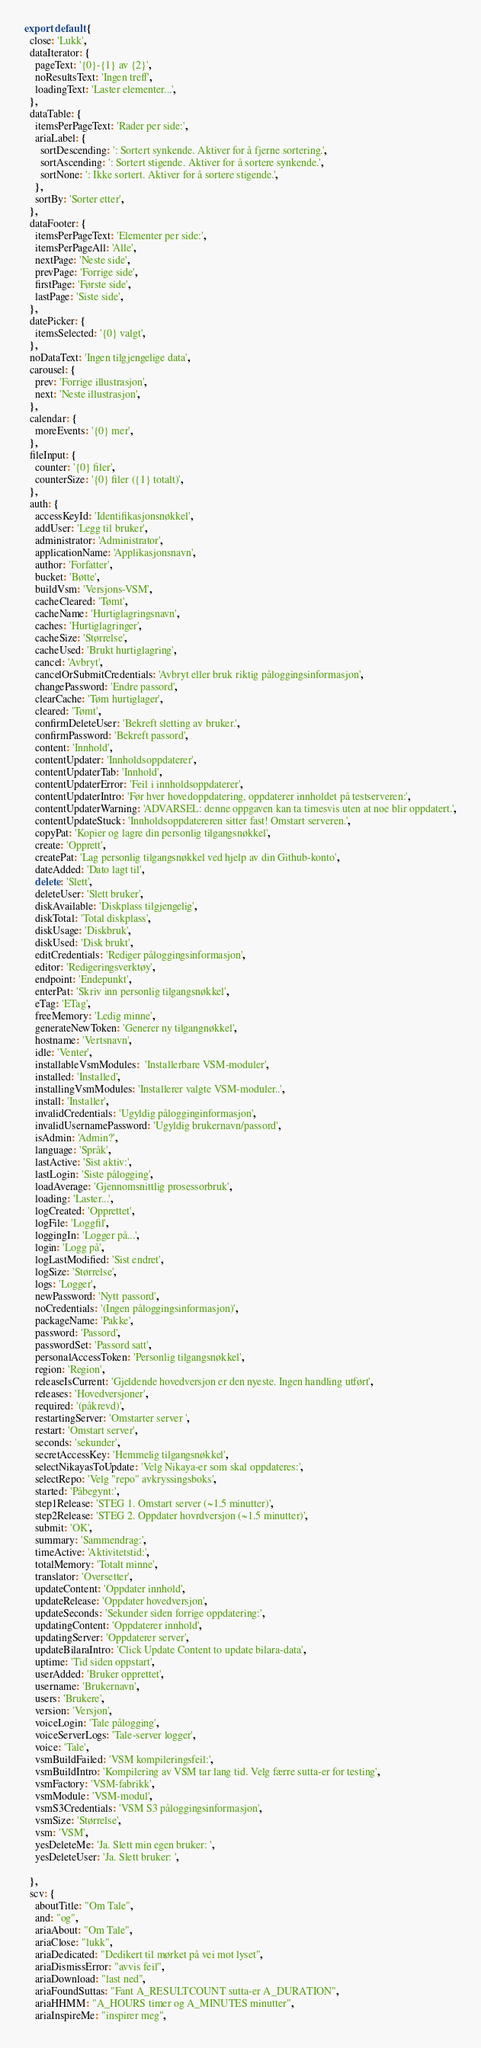<code> <loc_0><loc_0><loc_500><loc_500><_TypeScript_>export default {
  close: 'Lukk',
  dataIterator: {
    pageText: '{0}-{1} av {2}',
    noResultsText: 'Ingen treff',
    loadingText: 'Laster elementer...',
  },
  dataTable: {
    itemsPerPageText: 'Rader per side:',
    ariaLabel: {
      sortDescending: ': Sortert synkende. Aktiver for å fjerne sortering.',
      sortAscending: ': Sortert stigende. Aktiver for å sortere synkende.',
      sortNone: ': Ikke sortert. Aktiver for å sortere stigende.',
    },
    sortBy: 'Sorter etter',
  },
  dataFooter: {
    itemsPerPageText: 'Elementer per side:',
    itemsPerPageAll: 'Alle',
    nextPage: 'Neste side',
    prevPage: 'Forrige side',
    firstPage: 'Første side',
    lastPage: 'Siste side',
  },
  datePicker: {
    itemsSelected: '{0} valgt',
  },
  noDataText: 'Ingen tilgjengelige data',
  carousel: {
    prev: 'Forrige illustrasjon',
    next: 'Neste illustrasjon',
  },
  calendar: {
    moreEvents: '{0} mer',
  },
  fileInput: {
    counter: '{0} filer',
    counterSize: '{0} filer ({1} totalt)',
  },
  auth: {
    accessKeyId: 'Identifikasjonsnøkkel',
    addUser: 'Legg til bruker',
    administrator: 'Administrator',
    applicationName: 'Applikasjonsnavn',
    author: 'Forfatter',
    bucket: 'Bøtte',
    buildVsm: 'Versjons-VSM',
    cacheCleared: 'Tømt',
    cacheName: 'Hurtiglagringsnavn',
    caches: 'Hurtiglagringer',
    cacheSize: 'Størrelse',
    cacheUsed: 'Brukt hurtiglagring',
    cancel: 'Avbryt',
    cancelOrSubmitCredentials: 'Avbryt eller bruk riktig påloggingsinformasjon',
    changePassword: 'Endre passord',
    clearCache: 'Tøm hurtiglager',
    cleared: 'Tømt',
    confirmDeleteUser: 'Bekreft sletting av bruker.',
    confirmPassword: 'Bekreft passord',
    content: 'Innhold',
    contentUpdater: 'Innholdsoppdaterer',
    contentUpdaterTab: 'Innhold',
    contentUpdaterError: 'Feil i innholdsoppdaterer',
    contentUpdaterIntro: 'Før hver hovedoppdatering, oppdaterer innholdet på testserveren:',
    contentUpdaterWarning: 'ADVARSEL: denne oppgaven kan ta timesvis uten at noe blir oppdatert.',
    contentUpdateStuck: 'Innholdsoppdatereren sitter fast! Omstart serveren.',
    copyPat: 'Kopier og lagre din personlig tilgangsnøkkel',
    create: 'Opprett',
    createPat: 'Lag personlig tilgangsnøkkel ved hjelp av din Github-konto',
    dateAdded: 'Dato lagt til',
    delete: 'Slett',
    deleteUser: 'Slett bruker',
    diskAvailable: 'Diskplass tilgjengelig',
    diskTotal: 'Total diskplass',
    diskUsage: 'Diskbruk',
    diskUsed: 'Disk brukt',
    editCredentials: 'Rediger påloggingsinformasjon',
    editor: 'Redigeringsverktøy',
    endpoint: 'Endepunkt',
    enterPat: 'Skriv inn personlig tilgangsnøkkel',
    eTag: 'ETag',
    freeMemory: 'Ledig minne',
    generateNewToken: 'Generer ny tilgangnøkkel',
    hostname: 'Vertsnavn',
    idle: 'Venter',
    installableVsmModules:  'Installerbare VSM-moduler',
    installed: 'Installed',
    installingVsmModules: 'Installerer valgte VSM-moduler..',
    install: 'Installer',
    invalidCredentials: 'Ugyldig pålogginginformasjon',
    invalidUsernamePassword: 'Ugyldig brukernavn/passord',
    isAdmin: 'Admin?',
    language: 'Språk',
    lastActive: 'Sist aktiv:',
    lastLogin: 'Siste pålogging',
    loadAverage: 'Gjennomsnittlig prosessorbruk',
    loading: 'Laster...',
    logCreated: 'Opprettet',
    logFile: 'Loggfil',
    loggingIn: 'Logger på...',
    login: 'Logg på',
    logLastModified: 'Sist endret',
    logSize: 'Størrelse',
    logs: 'Logger',
    newPassword: 'Nytt passord',
    noCredentials: '(Ingen påloggingsinformasjon)',
    packageName: 'Pakke',
    password: 'Passord',
    passwordSet: 'Passord satt',
    personalAccessToken: 'Personlig tilgangsnøkkel',
    region: 'Region',
    releaseIsCurrent: 'Gjeldende hovedversjon er den nyeste. Ingen handling utført',
    releases: 'Hovedversjoner',
    required: '(påkrevd)',
    restartingServer: 'Omstarter server ',
    restart: 'Omstart server',
    seconds: 'sekunder',
    secretAccessKey: 'Hemmelig tilgangsnøkkel',
    selectNikayasToUpdate: 'Velg Nikaya-er som skal oppdateres:',
    selectRepo: 'Velg "repo" avkryssingsboks',
    started: 'Påbegynt:',
    step1Release: 'STEG 1. Omstart server (~1.5 minutter)',
    step2Release: 'STEG 2. Oppdater hovrdversjon (~1.5 minutter)',
    submit: 'OK',
    summary: 'Sammendrag:',
    timeActive: 'Aktivitetstid:',
    totalMemory: 'Totalt minne',
    translator: 'Oversetter',
    updateContent: 'Oppdater innhold',
    updateRelease: 'Oppdater hovedversjon',
    updateSeconds: 'Sekunder siden forrige oppdatering:',
    updatingContent: 'Oppdaterer innhold',
    updatingServer: 'Oppdaterer server',
    updateBilaraIntro: 'Click Update Content to update bilara-data',
    uptime: 'Tid siden oppstart',
    userAdded: 'Bruker opprettet',
    username: 'Brukernavn',
    users: 'Brukere',
    version: 'Versjon',
    voiceLogin: 'Tale pålogging',
    voiceServerLogs: 'Tale-server logger',
    voice: 'Tale',
    vsmBuildFailed: 'VSM kompileringsfeil:',
    vsmBuildIntro: 'Kompilering av VSM tar lang tid. Velg færre sutta-er for testing',
    vsmFactory: 'VSM-fabrikk',
    vsmModule: 'VSM-modul',
    vsmS3Credentials: 'VSM S3 påloggingsinformasjon',
    vsmSize: 'Størrelse',
    vsm: 'VSM',
    yesDeleteMe: 'Ja. Slett min egen bruker: ',
    yesDeleteUser: 'Ja. Slett bruker: ',

  },
  scv: {
    aboutTitle: "Om Tale",
    and: "og",
    ariaAbout: "Om Tale",
    ariaClose: "lukk",
    ariaDedicated: "Dedikert til mørket på vei mot lyset",
    ariaDismissError: "avvis feil",
    ariaDownload: "last ned",
    ariaFoundSuttas: "Fant A_RESULTCOUNT sutta-er A_DURATION",
    ariaHHMM: "A_HOURS timer og A_MINUTES minutter",
    ariaInspireMe: "inspirer meg",</code> 